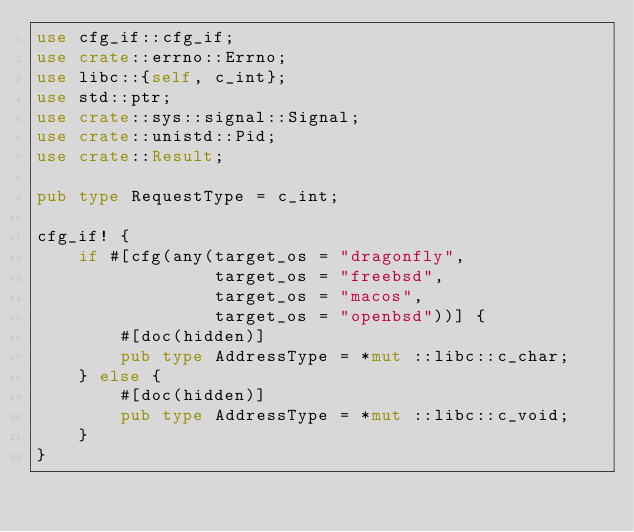<code> <loc_0><loc_0><loc_500><loc_500><_Rust_>use cfg_if::cfg_if;
use crate::errno::Errno;
use libc::{self, c_int};
use std::ptr;
use crate::sys::signal::Signal;
use crate::unistd::Pid;
use crate::Result;

pub type RequestType = c_int;

cfg_if! {
    if #[cfg(any(target_os = "dragonfly", 
                 target_os = "freebsd", 
                 target_os = "macos",
                 target_os = "openbsd"))] {
        #[doc(hidden)]
        pub type AddressType = *mut ::libc::c_char;
    } else {
        #[doc(hidden)]
        pub type AddressType = *mut ::libc::c_void;
    }
}
</code> 